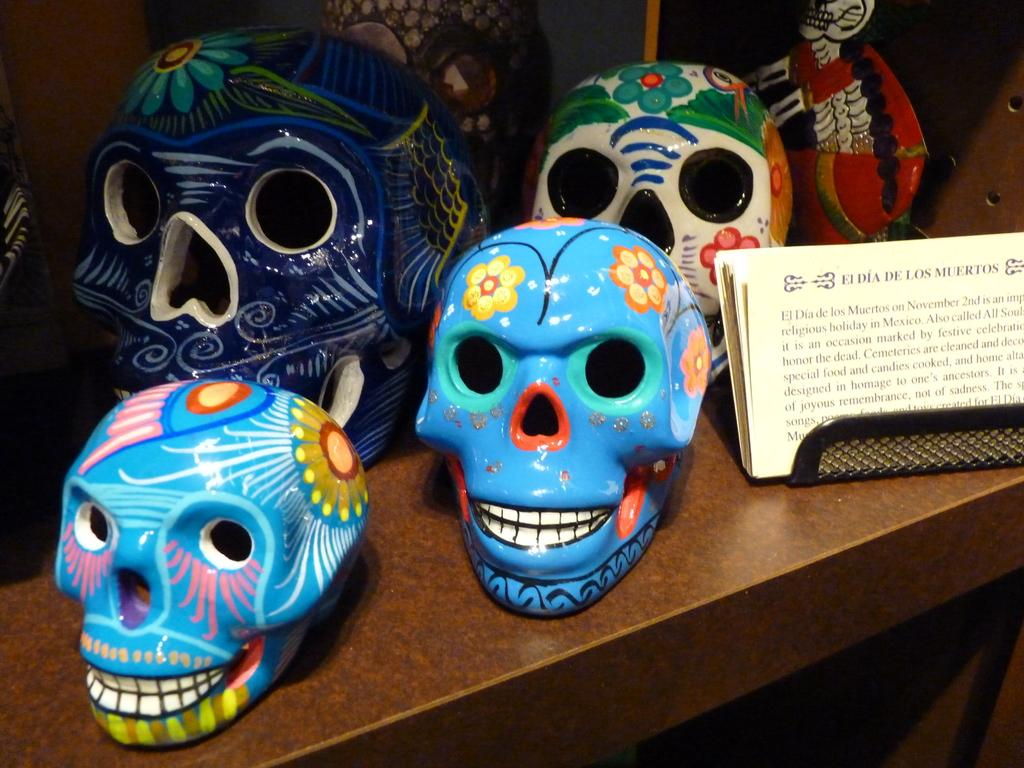What objects are on the table in the image? There are skulls on the table in the image. How are the skulls decorated? The skulls are painted in different colors. What else can be seen beside the skulls on the table? There are papers with a note beside the skulls. What type of weather can be seen in the image? There is no weather depicted in the image, as it is a still scene featuring skulls and papers on a table. 